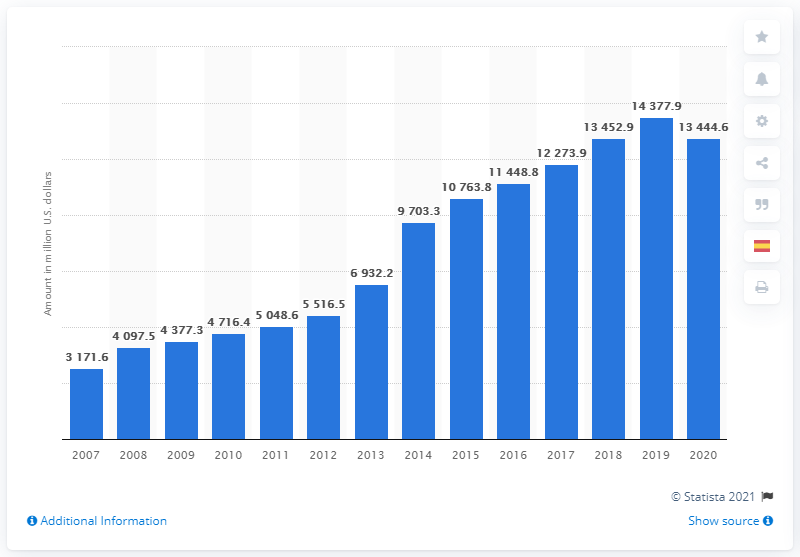Specify some key components in this picture. Biogen's revenue in 2020 was 13,444.6 million dollars. 